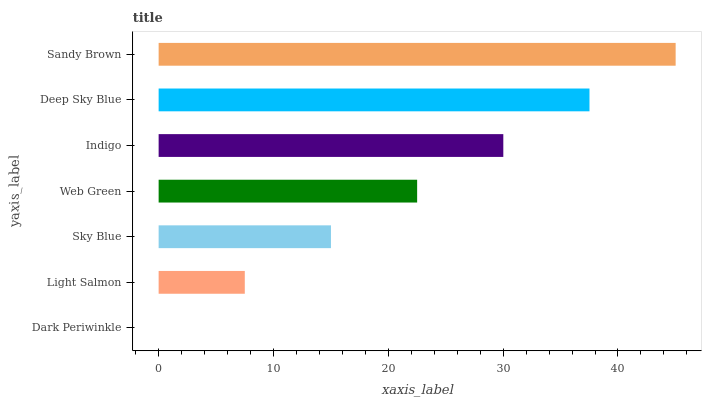Is Dark Periwinkle the minimum?
Answer yes or no. Yes. Is Sandy Brown the maximum?
Answer yes or no. Yes. Is Light Salmon the minimum?
Answer yes or no. No. Is Light Salmon the maximum?
Answer yes or no. No. Is Light Salmon greater than Dark Periwinkle?
Answer yes or no. Yes. Is Dark Periwinkle less than Light Salmon?
Answer yes or no. Yes. Is Dark Periwinkle greater than Light Salmon?
Answer yes or no. No. Is Light Salmon less than Dark Periwinkle?
Answer yes or no. No. Is Web Green the high median?
Answer yes or no. Yes. Is Web Green the low median?
Answer yes or no. Yes. Is Light Salmon the high median?
Answer yes or no. No. Is Indigo the low median?
Answer yes or no. No. 